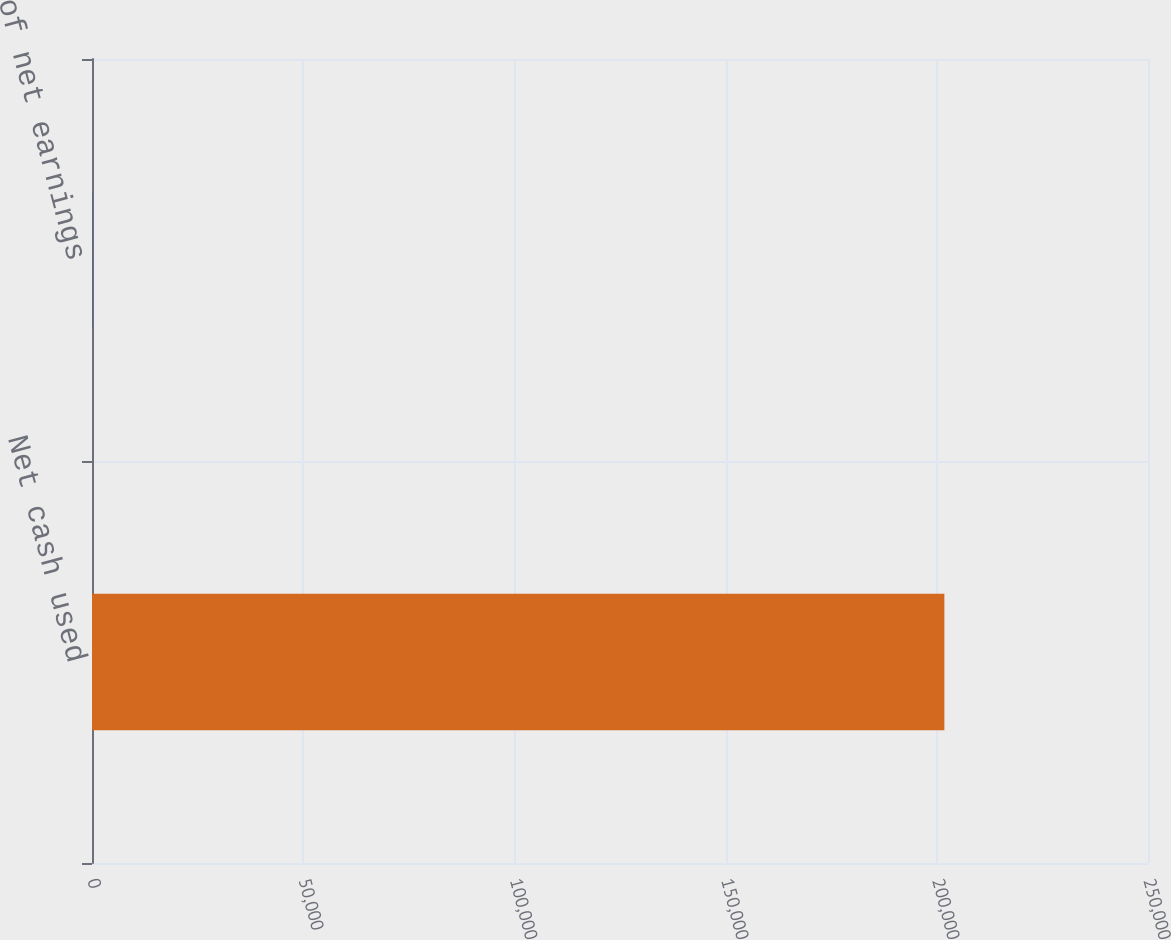<chart> <loc_0><loc_0><loc_500><loc_500><bar_chart><fcel>Net cash used<fcel>of net earnings<nl><fcel>201792<fcel>45<nl></chart> 